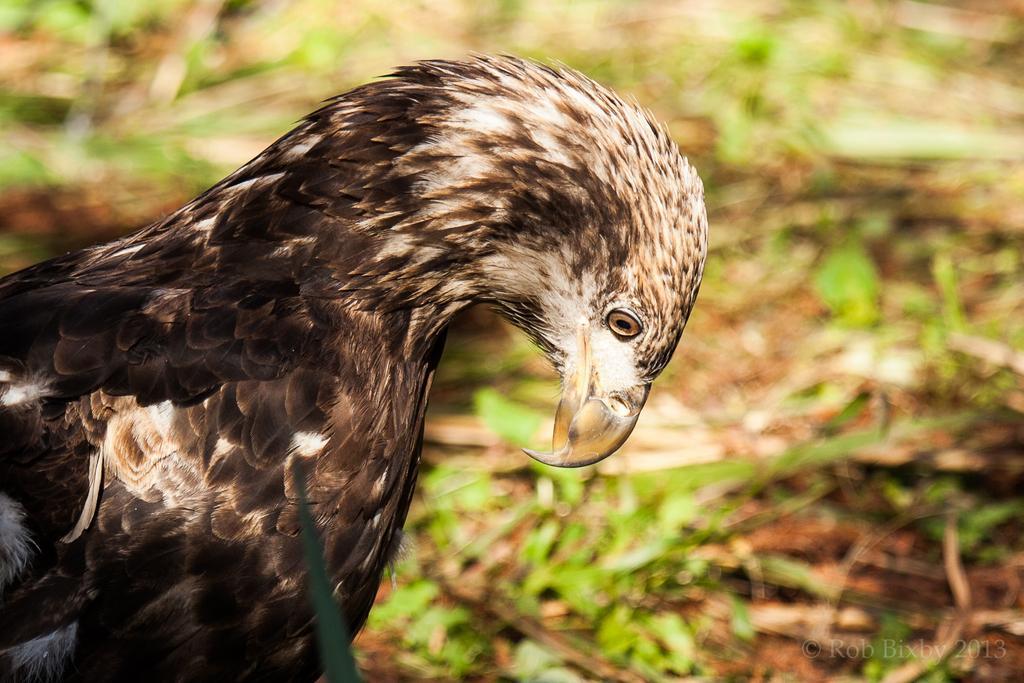Please provide a concise description of this image. In this image we can see a bird, and the grass, also the background is blurred. 